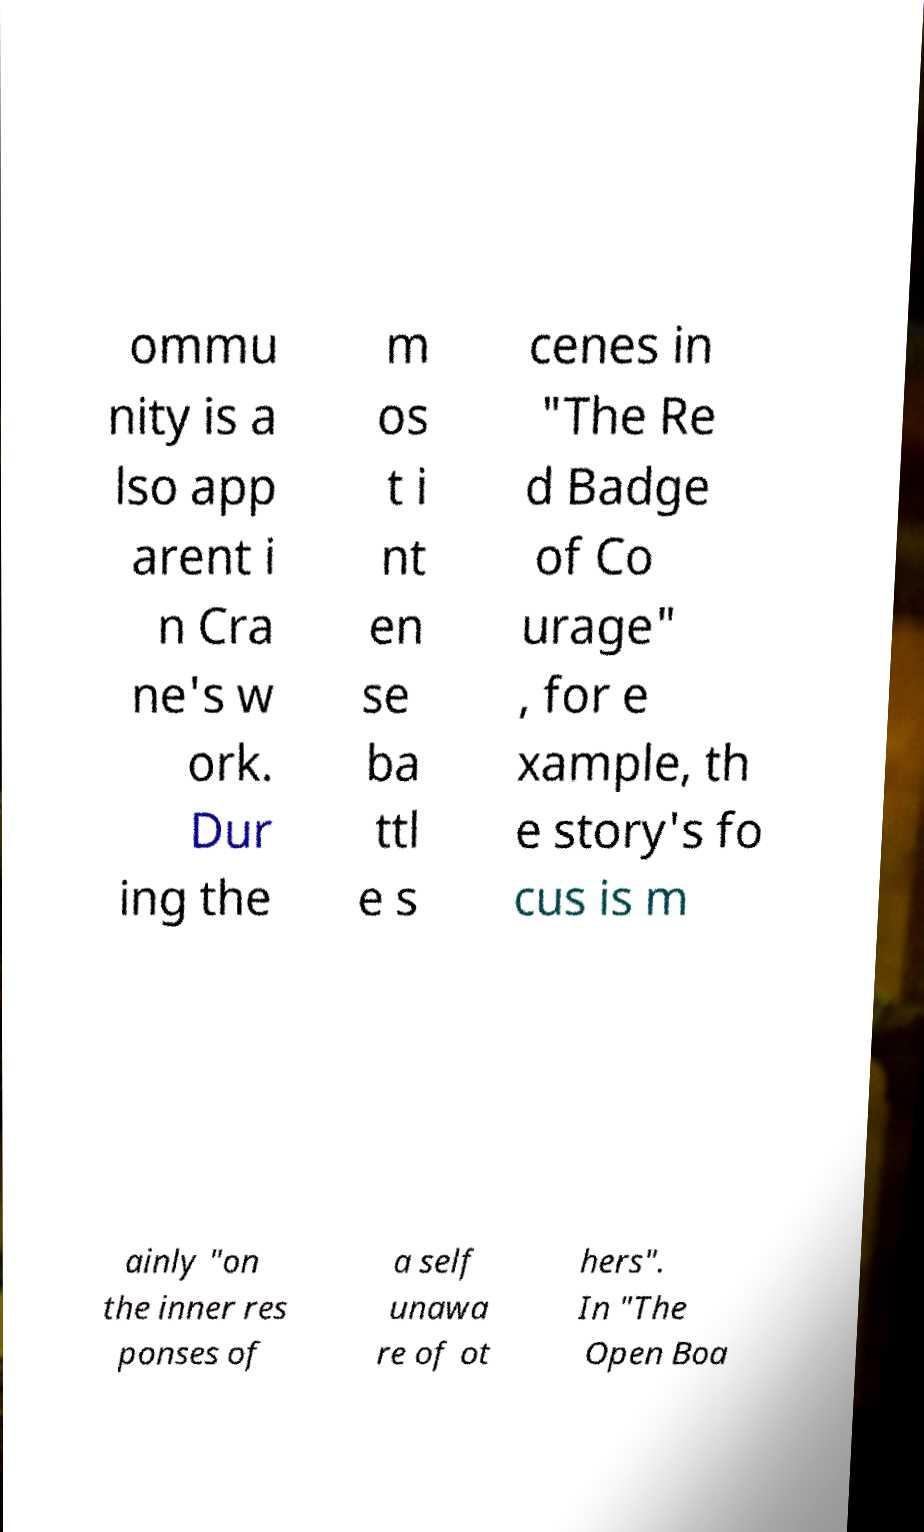Could you assist in decoding the text presented in this image and type it out clearly? ommu nity is a lso app arent i n Cra ne's w ork. Dur ing the m os t i nt en se ba ttl e s cenes in "The Re d Badge of Co urage" , for e xample, th e story's fo cus is m ainly "on the inner res ponses of a self unawa re of ot hers". In "The Open Boa 